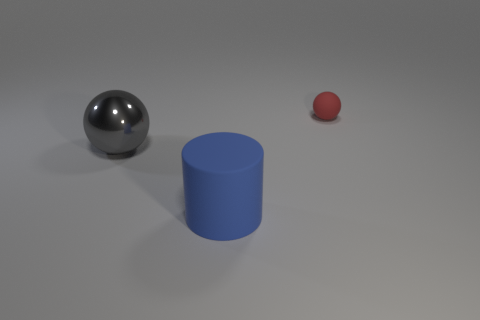Subtract all spheres. How many objects are left? 1 Subtract all brown cylinders. How many gray balls are left? 1 Add 2 gray spheres. How many objects exist? 5 Subtract all large red balls. Subtract all small red balls. How many objects are left? 2 Add 2 cylinders. How many cylinders are left? 3 Add 2 blue cylinders. How many blue cylinders exist? 3 Subtract 1 red balls. How many objects are left? 2 Subtract all green balls. Subtract all blue cubes. How many balls are left? 2 